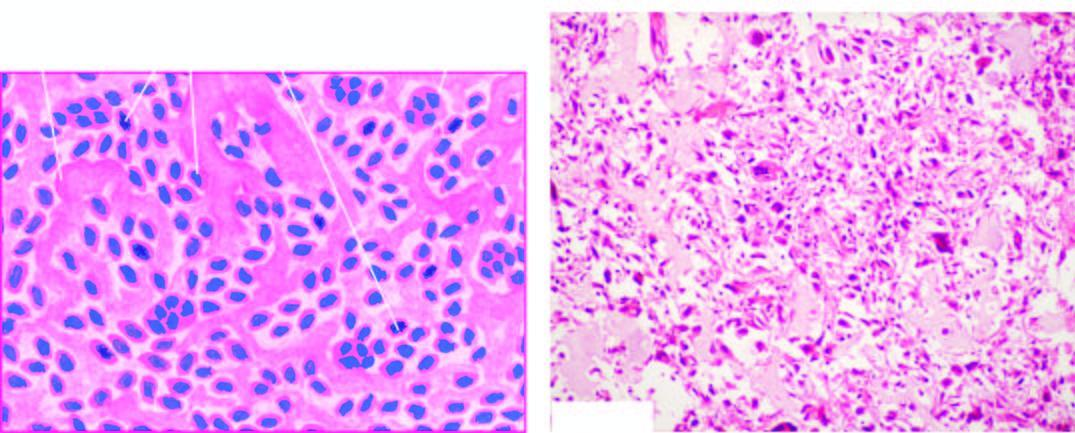re a few intact hepatic lobules the sarcoma cells characterised by variation in size and shape of tumour cells, bizarre mitosis and multinucleate tumour giant cells, and osteogenesis ie?
Answer the question using a single word or phrase. No 